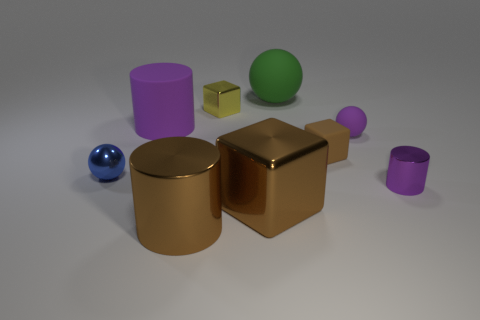Subtract all spheres. How many objects are left? 6 Subtract all cyan metal objects. Subtract all brown cylinders. How many objects are left? 8 Add 7 brown matte blocks. How many brown matte blocks are left? 8 Add 1 purple metal things. How many purple metal things exist? 2 Subtract 0 gray cylinders. How many objects are left? 9 